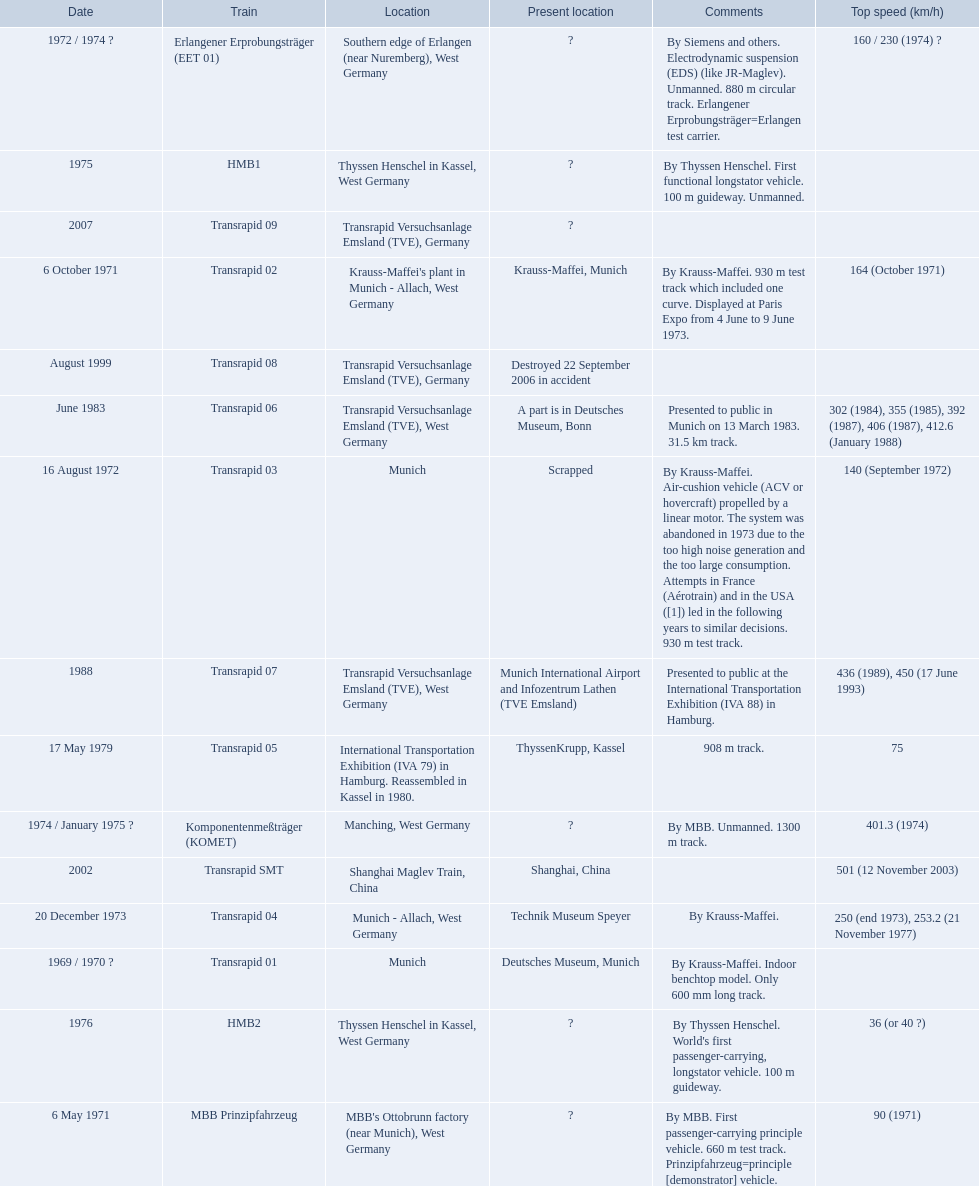What are all of the transrapid trains? Transrapid 01, Transrapid 02, Transrapid 03, Transrapid 04, Transrapid 05, Transrapid 06, Transrapid 07, Transrapid 08, Transrapid SMT, Transrapid 09. Of those, which train had to be scrapped? Transrapid 03. 